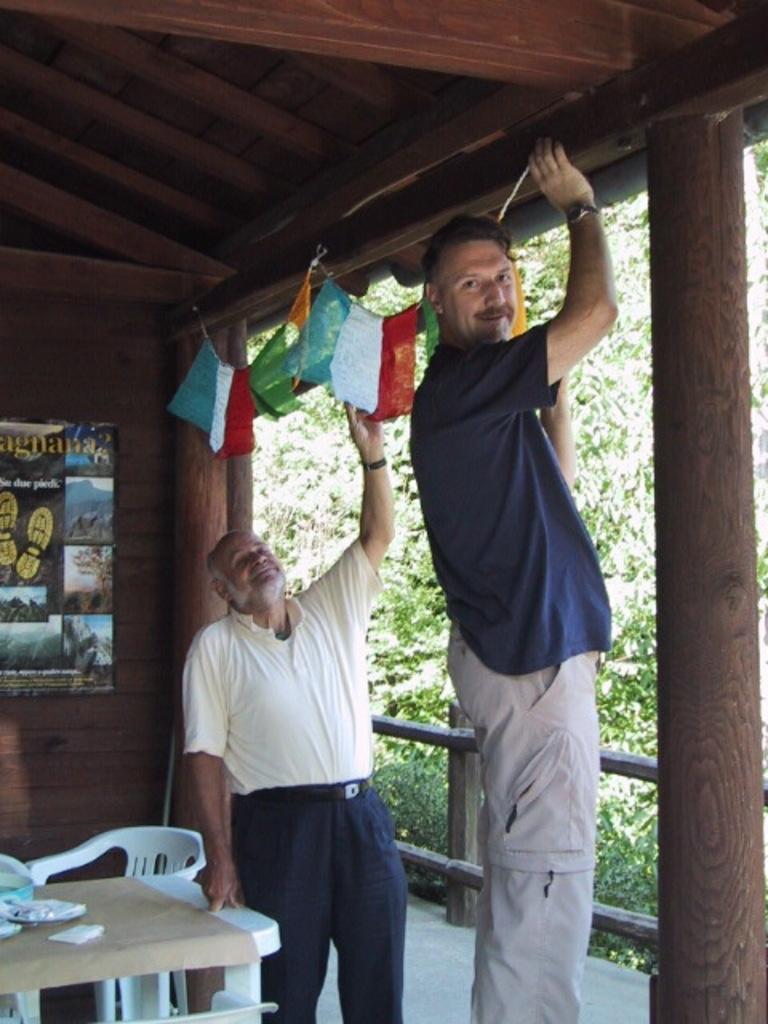Could you give a brief overview of what you see in this image? In the picture there is a tall man and short man standing. The tall man is holding a thread and the short man is holding a flag. To left of the image there is poster sticked on the wall. To the below left corner of the image there is a table and chair and things placed on the table. There are some flags hanged. Behind the people there is railing and trees. 